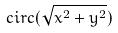Convert formula to latex. <formula><loc_0><loc_0><loc_500><loc_500>c i r c ( \sqrt { x ^ { 2 } + y ^ { 2 } } )</formula> 